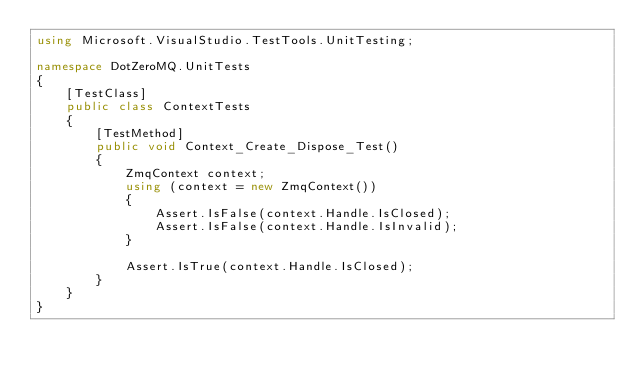Convert code to text. <code><loc_0><loc_0><loc_500><loc_500><_C#_>using Microsoft.VisualStudio.TestTools.UnitTesting;

namespace DotZeroMQ.UnitTests
{
    [TestClass]
    public class ContextTests
    {
        [TestMethod]
        public void Context_Create_Dispose_Test()
        {
            ZmqContext context;
            using (context = new ZmqContext())
            {
                Assert.IsFalse(context.Handle.IsClosed);
                Assert.IsFalse(context.Handle.IsInvalid);
            }
            
            Assert.IsTrue(context.Handle.IsClosed);
        }
    }
}</code> 